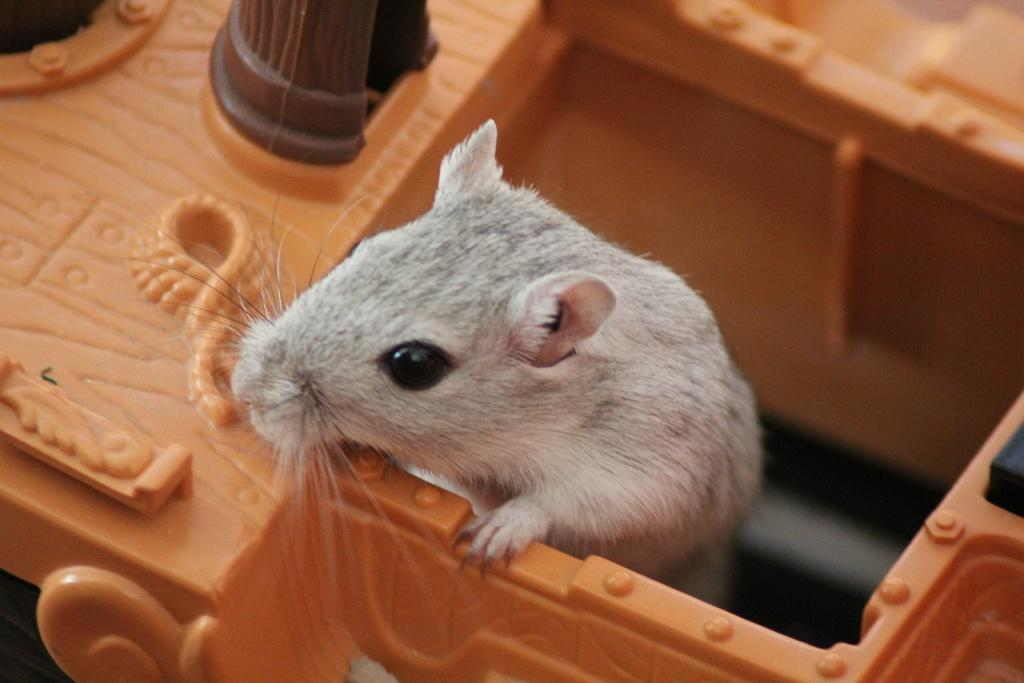What type of animal is in the image? There is a white-colored rat in the image. What is the rat sitting on? The rat is on a plastic object. In which direction is the rat looking? The rat is looking towards the left side. What grade does the rat receive for its performance on the tramp? There is no tramp or performance in the image, and therefore no grade can be assigned. 